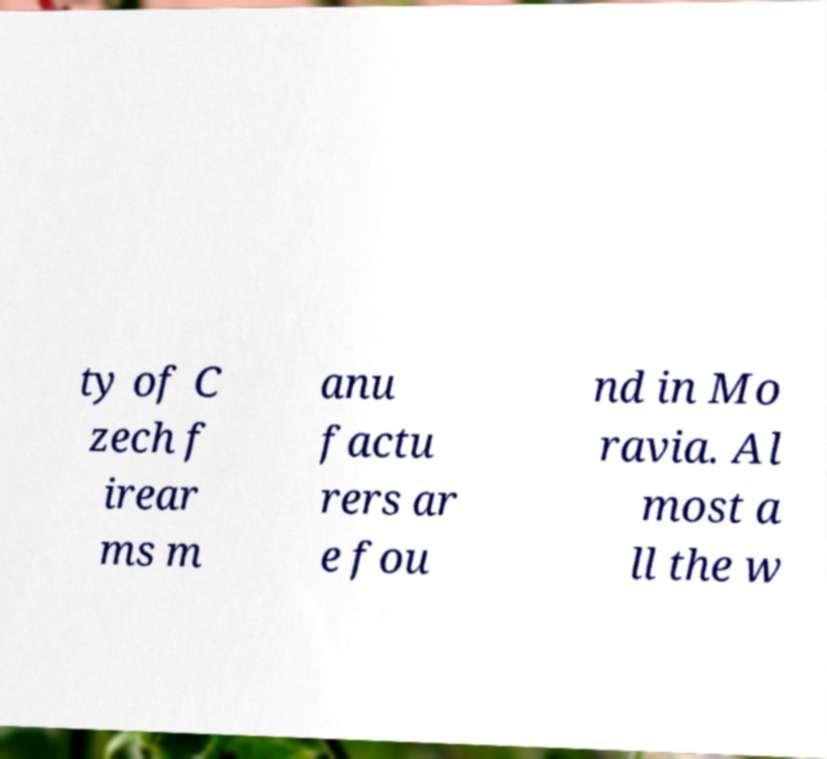There's text embedded in this image that I need extracted. Can you transcribe it verbatim? ty of C zech f irear ms m anu factu rers ar e fou nd in Mo ravia. Al most a ll the w 